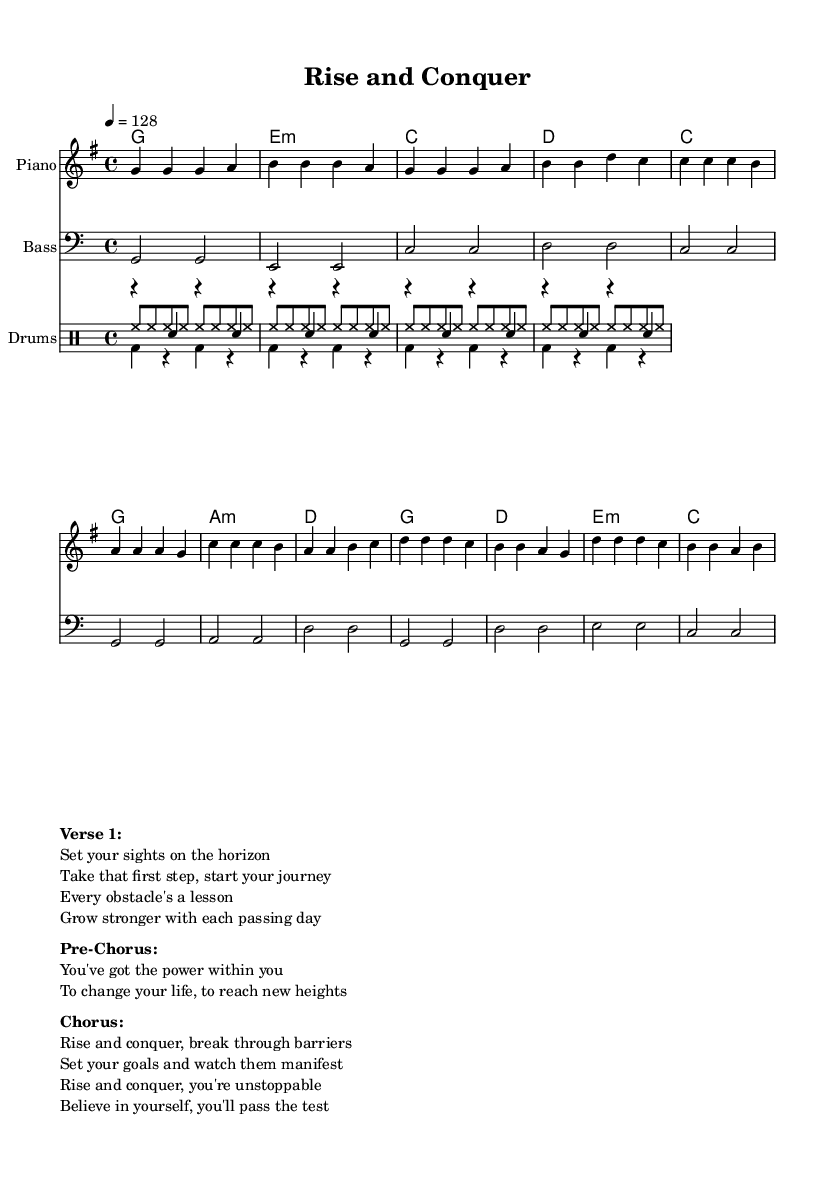What is the key signature of this music? The key signature can be found at the beginning of the sheet music, and it indicates G major, which has one sharp (F#).
Answer: G major What is the time signature of this music? The time signature is shown at the beginning and is represented as a fraction; in this case, it is 4/4, meaning there are four beats in a measure, and the quarter note gets one beat.
Answer: 4/4 What is the tempo marking for this piece? The tempo marking is indicated in beats per minute (BPM); here it is set to 128 beats per minute, suggesting a moderate and uplifting pace for the song.
Answer: 128 How many measures are in the chorus section? To find the number of measures in the chorus, we count each segment in the chorus notation, which contains four measures in total.
Answer: 4 What is the primary theme of the lyrics in the chorus? The lyrics in the chorus express a theme of empowerment and motivation, focusing on overcoming challenges and believing in oneself, with phrases like "Rise and conquer."
Answer: Empowerment How does the bassline relate to the melody in the chorus? The bassline follows a foundational role, supporting the melody by providing root notes that correlate with the chords in the harmony; specifically, it plays the G note corresponding to the G chord aligned with the melody.
Answer: Root notes What is the purpose of the pre-chorus section in pop music? The pre-chorus serves as a transition that builds anticipation towards the chorus, often increasing emotional intensity, as seen in the lyrics expressing self-empowerment before reaching the climactic chorus.
Answer: Build anticipation 